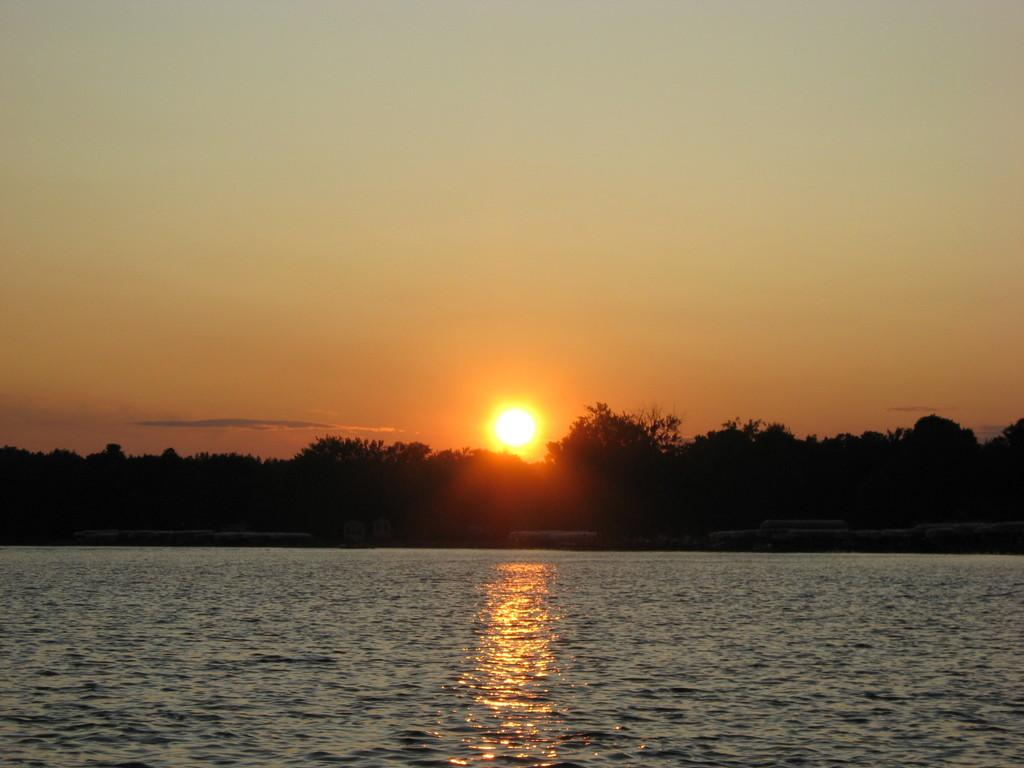What body of water is present in the image? There is a lake in the image. What type of vegetation can be seen in the background? Trees are visible in the background of the image. What is the position of the sun in the sky? The sun is setting down in the sky. Can you see any cats in the image that are stuck in quicksand? There are no cats or quicksand present in the image. 